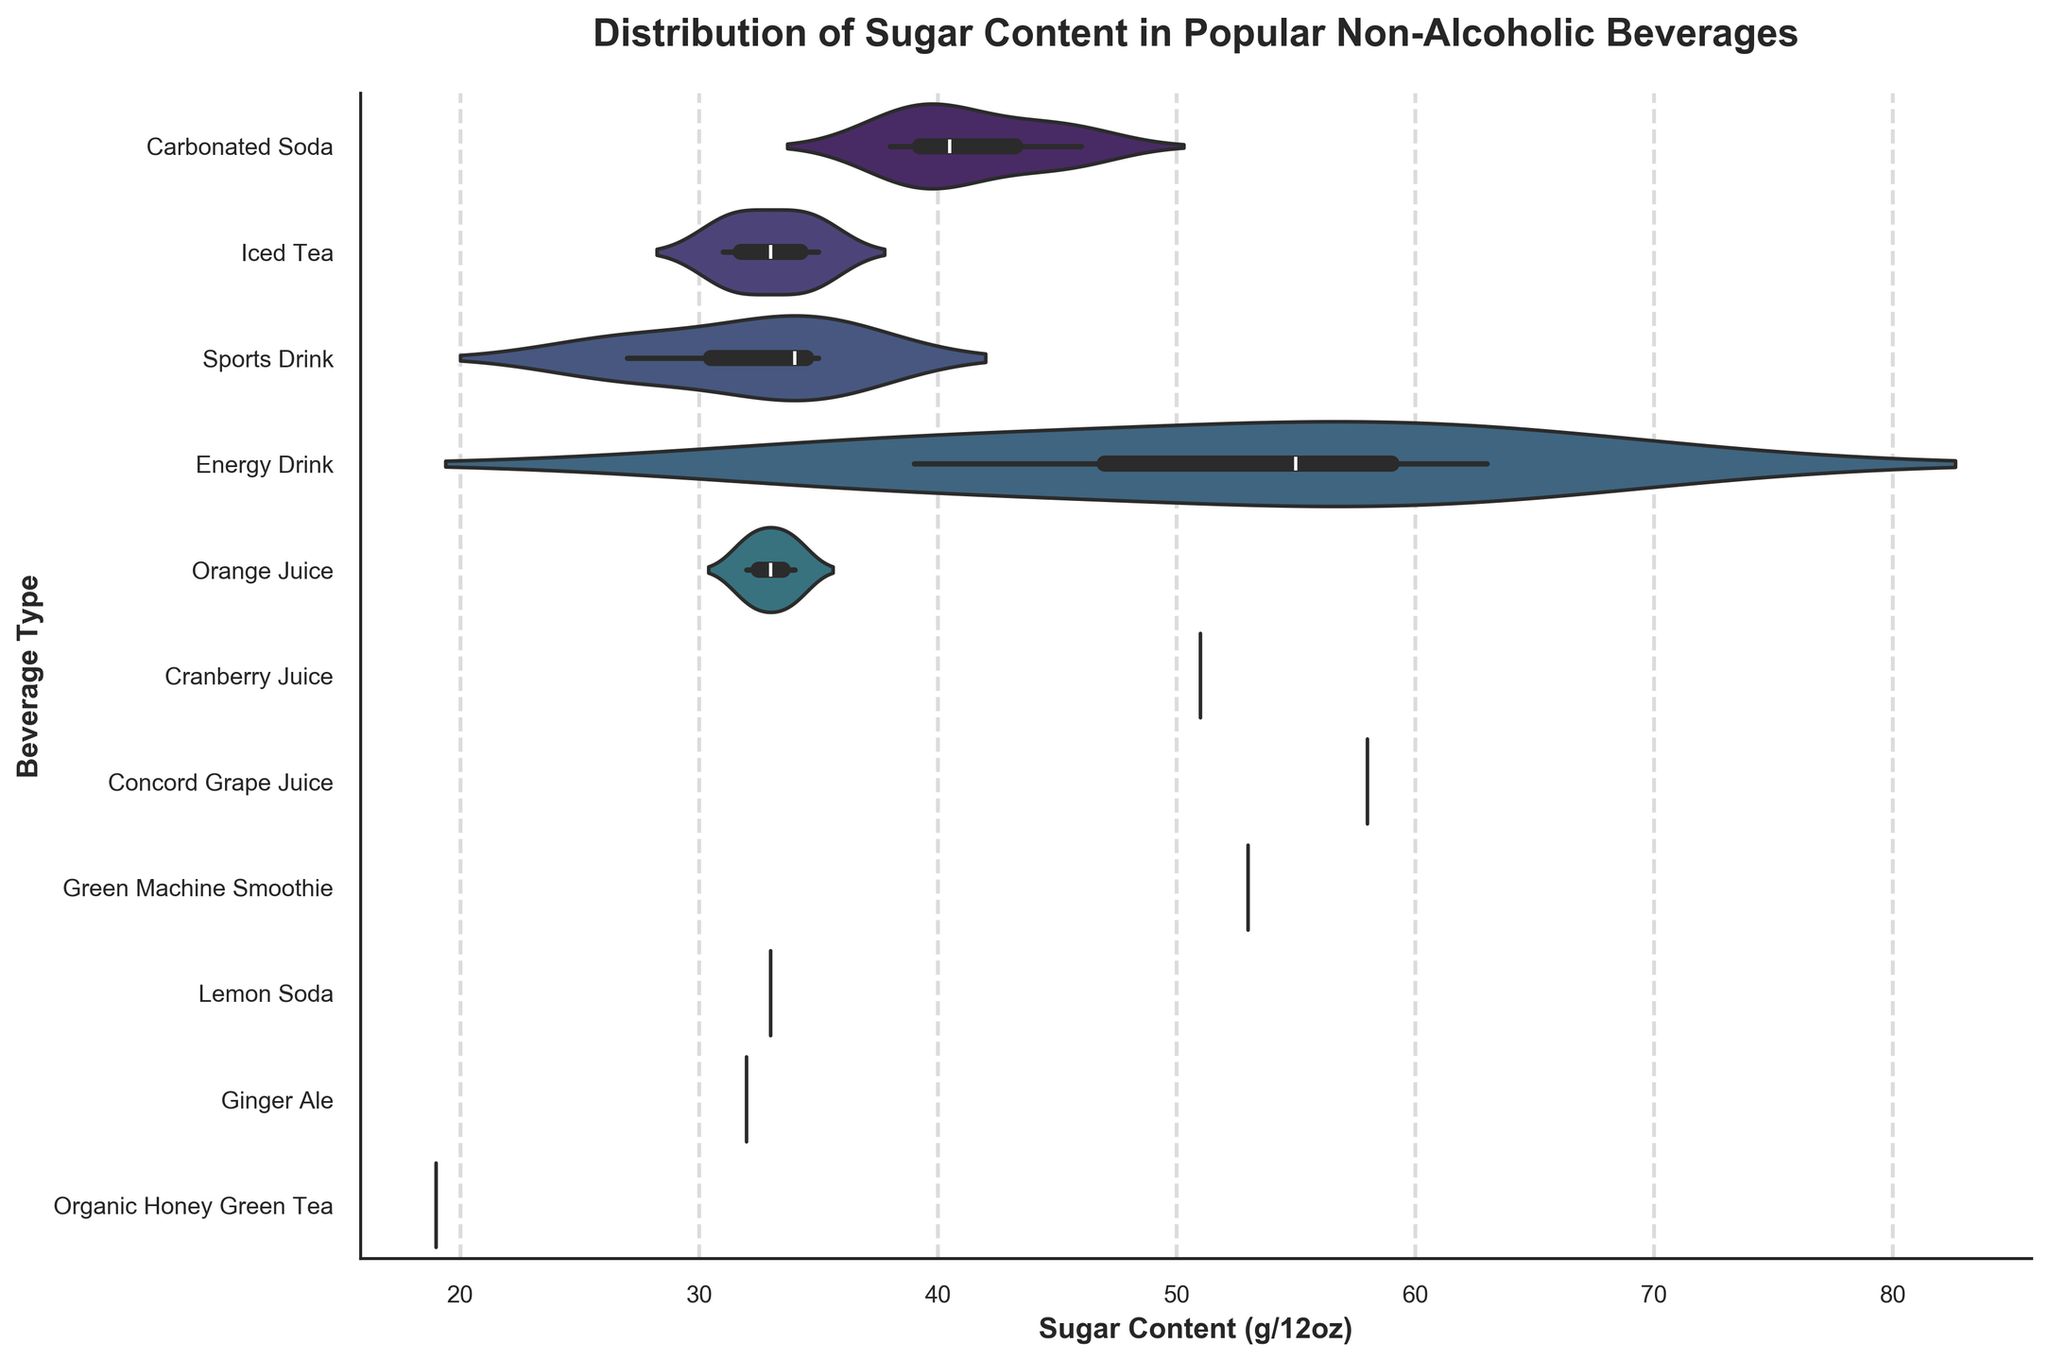What is the title of the figure? The title is located at the top of the figure and usually summarizes the main topic.
Answer: Distribution of Sugar Content in Popular Non-Alcoholic Beverages What is the range of sugar content for Carbonated Soda? Look at the spread of the horizontal violin plot for Carbonated Soda; it shows the range from the minimum to the maximum sugar content.
Answer: 38-46 g/12oz Which beverage type has the highest maximum sugar content? Identify the beverage type with the rightmost point in its violin plot.
Answer: Energy Drink How does the median sugar content of Iced Tea compare to Sports Drink? Check the line inside the violin plots for Iced Tea and Sports Drink representing the median values and compare their positions.
Answer: Iced Tea has a lower median sugar content than Sports Drink What is the range of sugar content in Orange Juice compared to Cranberry Juice? Examine the spread of the violin plots for both Orange Juice and Cranberry Juice; compare the minimum and maximum values.
Answer: Orange Juice: 32-34 g/12oz, Cranberry Juice: 51 g/12oz Among the beverage types shown, which ones have a sugar content below 30 g/12oz? Look for any violins where the range includes values below 30 g/12oz.
Answer: Sports Drink, Organic Honey Green Tea Which beverage type has the smallest interquartile range (IQR) of sugar content? Observe the width of the boxes inside the violins, which represent the IQR, and identify the smallest one.
Answer: Orange Juice How does the variability of sugar content in Energy Drinks compare to Carbonated Soda? Compare the width and height of the violin plots for both beverage types. Energy Drinks likely have a broader range, indicating higher variability.
Answer: Energy Drinks have more variability than Carbonated Soda What is the median sugar content in Lemon Soda? Check the central line in the violin plot for Lemon Soda, representing the median value.
Answer: 33 g/12oz 